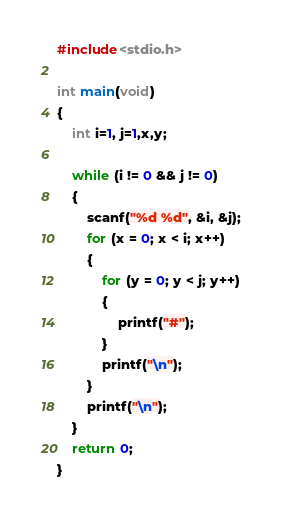<code> <loc_0><loc_0><loc_500><loc_500><_C_>#include<stdio.h>

int main(void)
{
	int i=1, j=1,x,y;

	while (i != 0 && j != 0)
	{
		scanf("%d %d", &i, &j);
		for (x = 0; x < i; x++)
		{
			for (y = 0; y < j; y++)
			{
				printf("#");
			}
			printf("\n");
		}
		printf("\n");
	}
	return 0;
}
</code> 